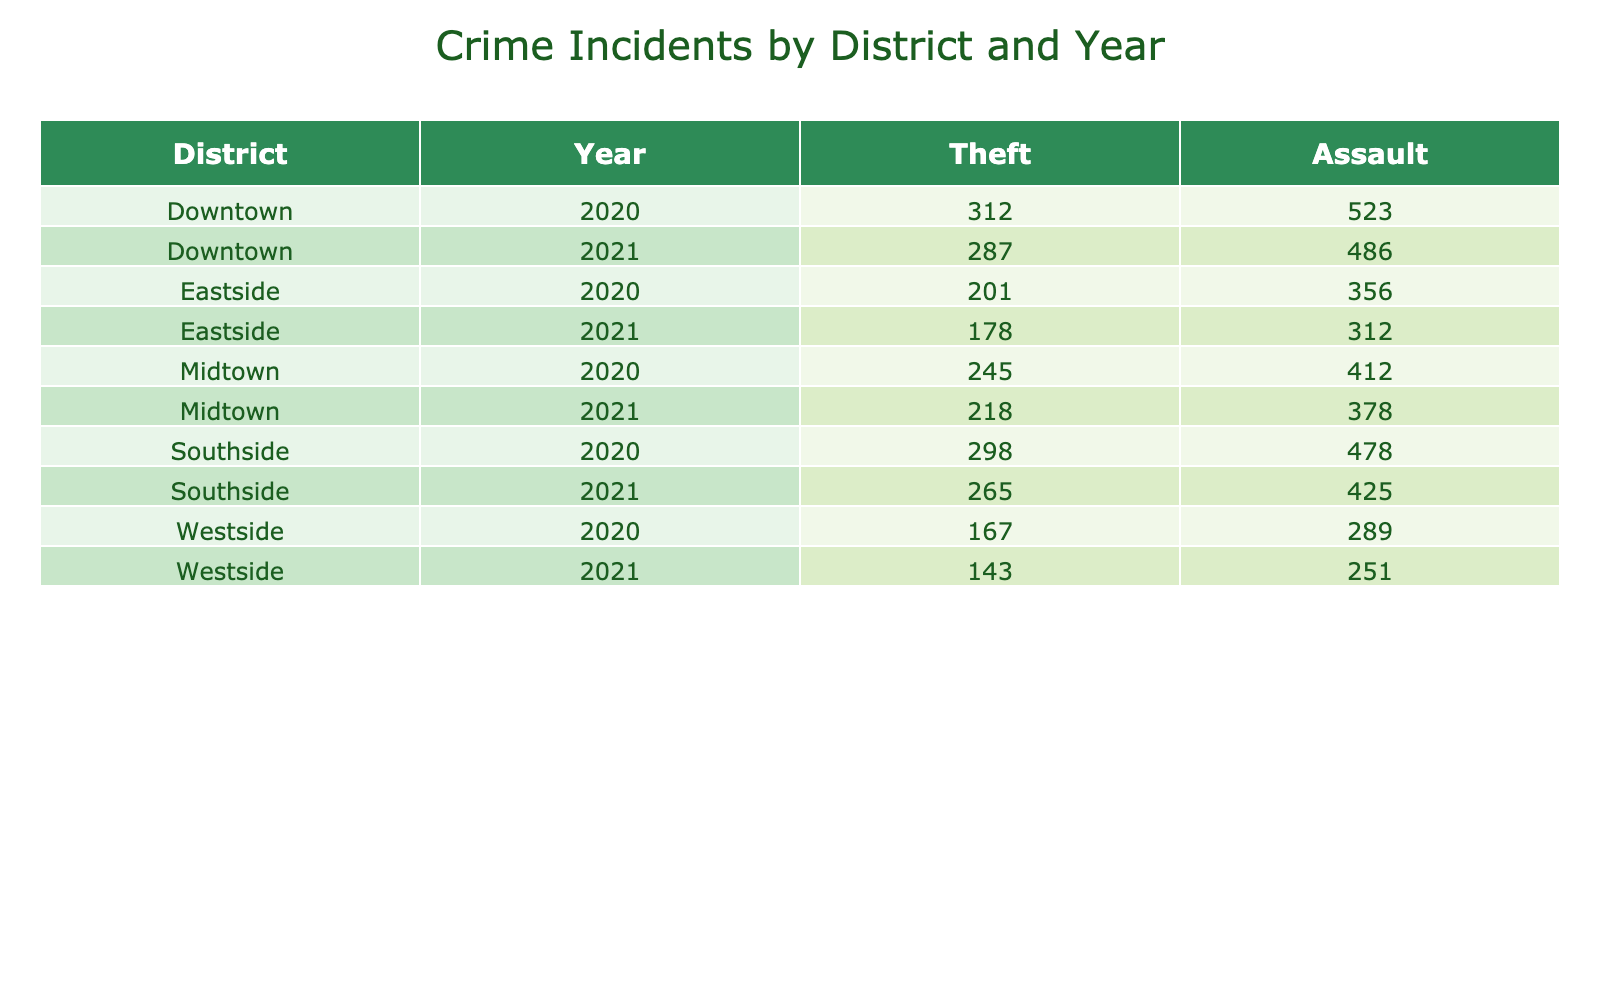What was the total number of theft incidents in Downtown in 2021? The table shows 'Theft' incidents for Downtown in 2021 as 486. Therefore, the total number of theft incidents in that district for the specified year is 486.
Answer: 486 How many assault incidents were reported in Midtown for 2020? According to the table, the number of assault incidents recorded in Midtown for 2020 is 245.
Answer: 245 Is there smart surveillance implemented in Eastside for 2021? By looking at the table, Eastside for 2021 shows 'Yes' under the Smart Surveillance Cameras column, indicating that smart surveillance is indeed implemented there for that year.
Answer: Yes What is the difference in theft incidents between Southside in 2020 and 2021? From the table, Southside had 478 theft incidents in 2020 and 425 incidents in 2021. To find the difference, we perform 478 - 425 = 53. Thus, Southside experienced 53 fewer theft incidents from 2020 to 2021.
Answer: 53 What were the total incidents of assault across all districts in 2021? For 2021, the assault incidents are as follows: Downtown has 287, Midtown has 218, Westside has 143, Eastside has 178, and Southside has 265. Adding these together gives a total of 287 + 218 + 143 + 178 + 265 = 1091 assault incidents in 2021.
Answer: 1091 In which district was the highest number of theft incidents recorded in 2021? Referring to the table for 2021, the theft incidents were: Downtown 486, Midtown 378, Westside 251, Eastside 312, and Southside 425. The highest number is in Downtown with 486 theft incidents.
Answer: Downtown What is the average predictive policing score for the districts that implemented smart surveillance in 2021? The districts with smart surveillance in 2021 are Downtown (8.1), Midtown (6.9), Westside (6.2), Eastside (6.7), and Southside (7.5). Adding these scores gives 8.1 + 6.9 + 6.2 + 6.7 + 7.5 = 35.4. There are 5 districts, so the average score is 35.4 / 5 = 7.08.
Answer: 7.08 How many districts reported no smart surveillance in 2020 and how many incidents of assault were recorded in those districts? By examining the table, Midtown (245 assault incidents) and Westside (167 assault incidents) had no smart surveillance in 2020. Summing the assault incidents yields 245 + 167 = 412. Therefore, 2 districts reported no smart surveillance, with a total of 412 assault incidents.
Answer: 412 Was the predictive policing score higher in 2020 or 2021 overall across all districts? For 2020, the scores indicate: Downtown (7.2), Midtown (5.8), Westside (4.5), Eastside (5.1), and Southside (6.3), giving a total of 28.9. The average for 2020 is 28.9 / 5 = 5.78. For 2021, the scores are: Downtown (8.1), Midtown (6.9), Westside (6.2), Eastside (6.7), Southside (7.5) totaling to 35.4, hence the average is 35.4 / 5 = 7.08. Since 7.08 > 5.78, the predictive policing score was higher in 2021.
Answer: 2021 